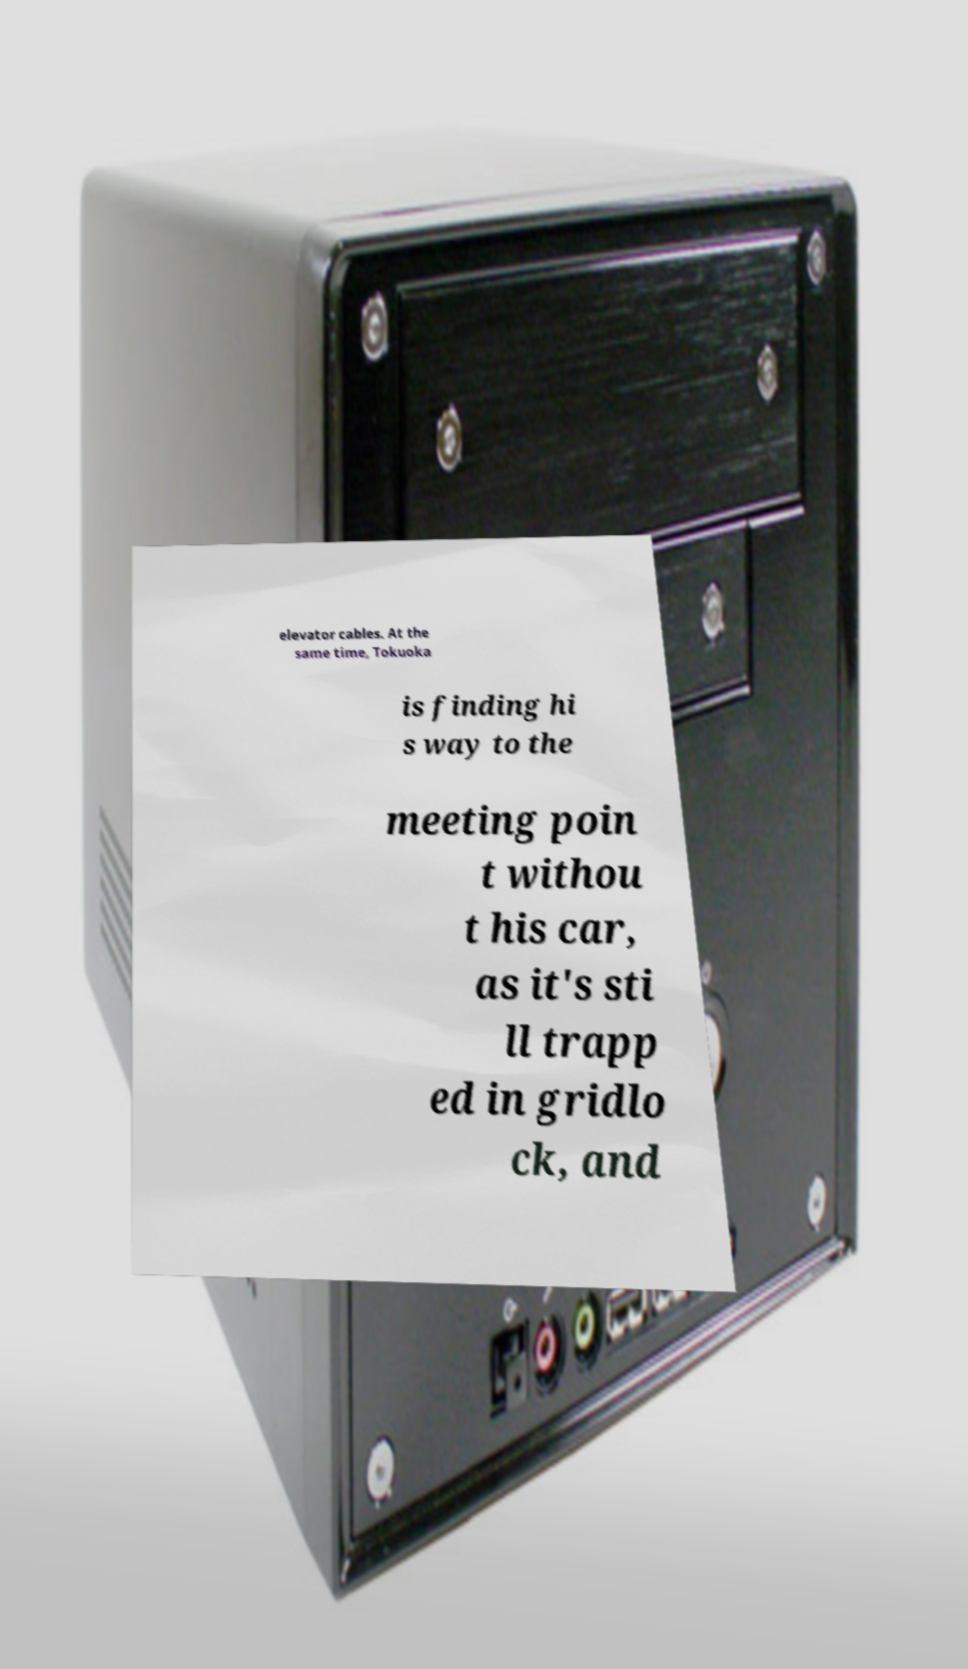Could you extract and type out the text from this image? elevator cables. At the same time, Tokuoka is finding hi s way to the meeting poin t withou t his car, as it's sti ll trapp ed in gridlo ck, and 